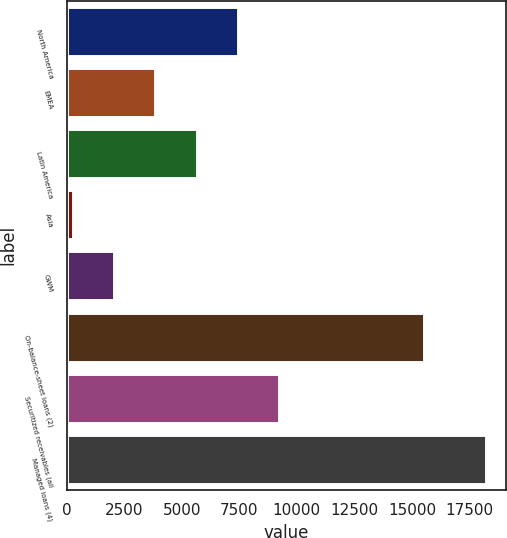Convert chart. <chart><loc_0><loc_0><loc_500><loc_500><bar_chart><fcel>North America<fcel>EMEA<fcel>Latin America<fcel>Asia<fcel>GWM<fcel>On-balance-sheet loans (2)<fcel>Securitized receivables (all<fcel>Managed loans (4)<nl><fcel>7435.6<fcel>3848.8<fcel>5642.2<fcel>262<fcel>2055.4<fcel>15541<fcel>9229<fcel>18196<nl></chart> 